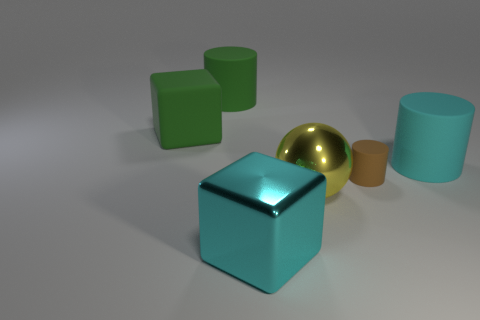Is the number of large blocks that are in front of the large yellow object the same as the number of big brown rubber cylinders?
Give a very brief answer. No. There is a big cube behind the cyan thing that is to the right of the yellow metal ball; how many cyan rubber cylinders are behind it?
Offer a terse response. 0. Is there any other thing that is the same size as the brown matte cylinder?
Your answer should be very brief. No. Is the size of the green cylinder the same as the block that is behind the large shiny sphere?
Your answer should be compact. Yes. What number of small blue balls are there?
Ensure brevity in your answer.  0. There is a cube that is left of the large cyan metallic cube; does it have the same size as the block in front of the big yellow shiny sphere?
Offer a terse response. Yes. What color is the other object that is the same shape as the large cyan metallic thing?
Give a very brief answer. Green. Is the yellow metallic thing the same shape as the tiny brown thing?
Keep it short and to the point. No. There is a green rubber thing that is the same shape as the cyan rubber object; what size is it?
Ensure brevity in your answer.  Large. How many cyan objects are the same material as the yellow object?
Ensure brevity in your answer.  1. 